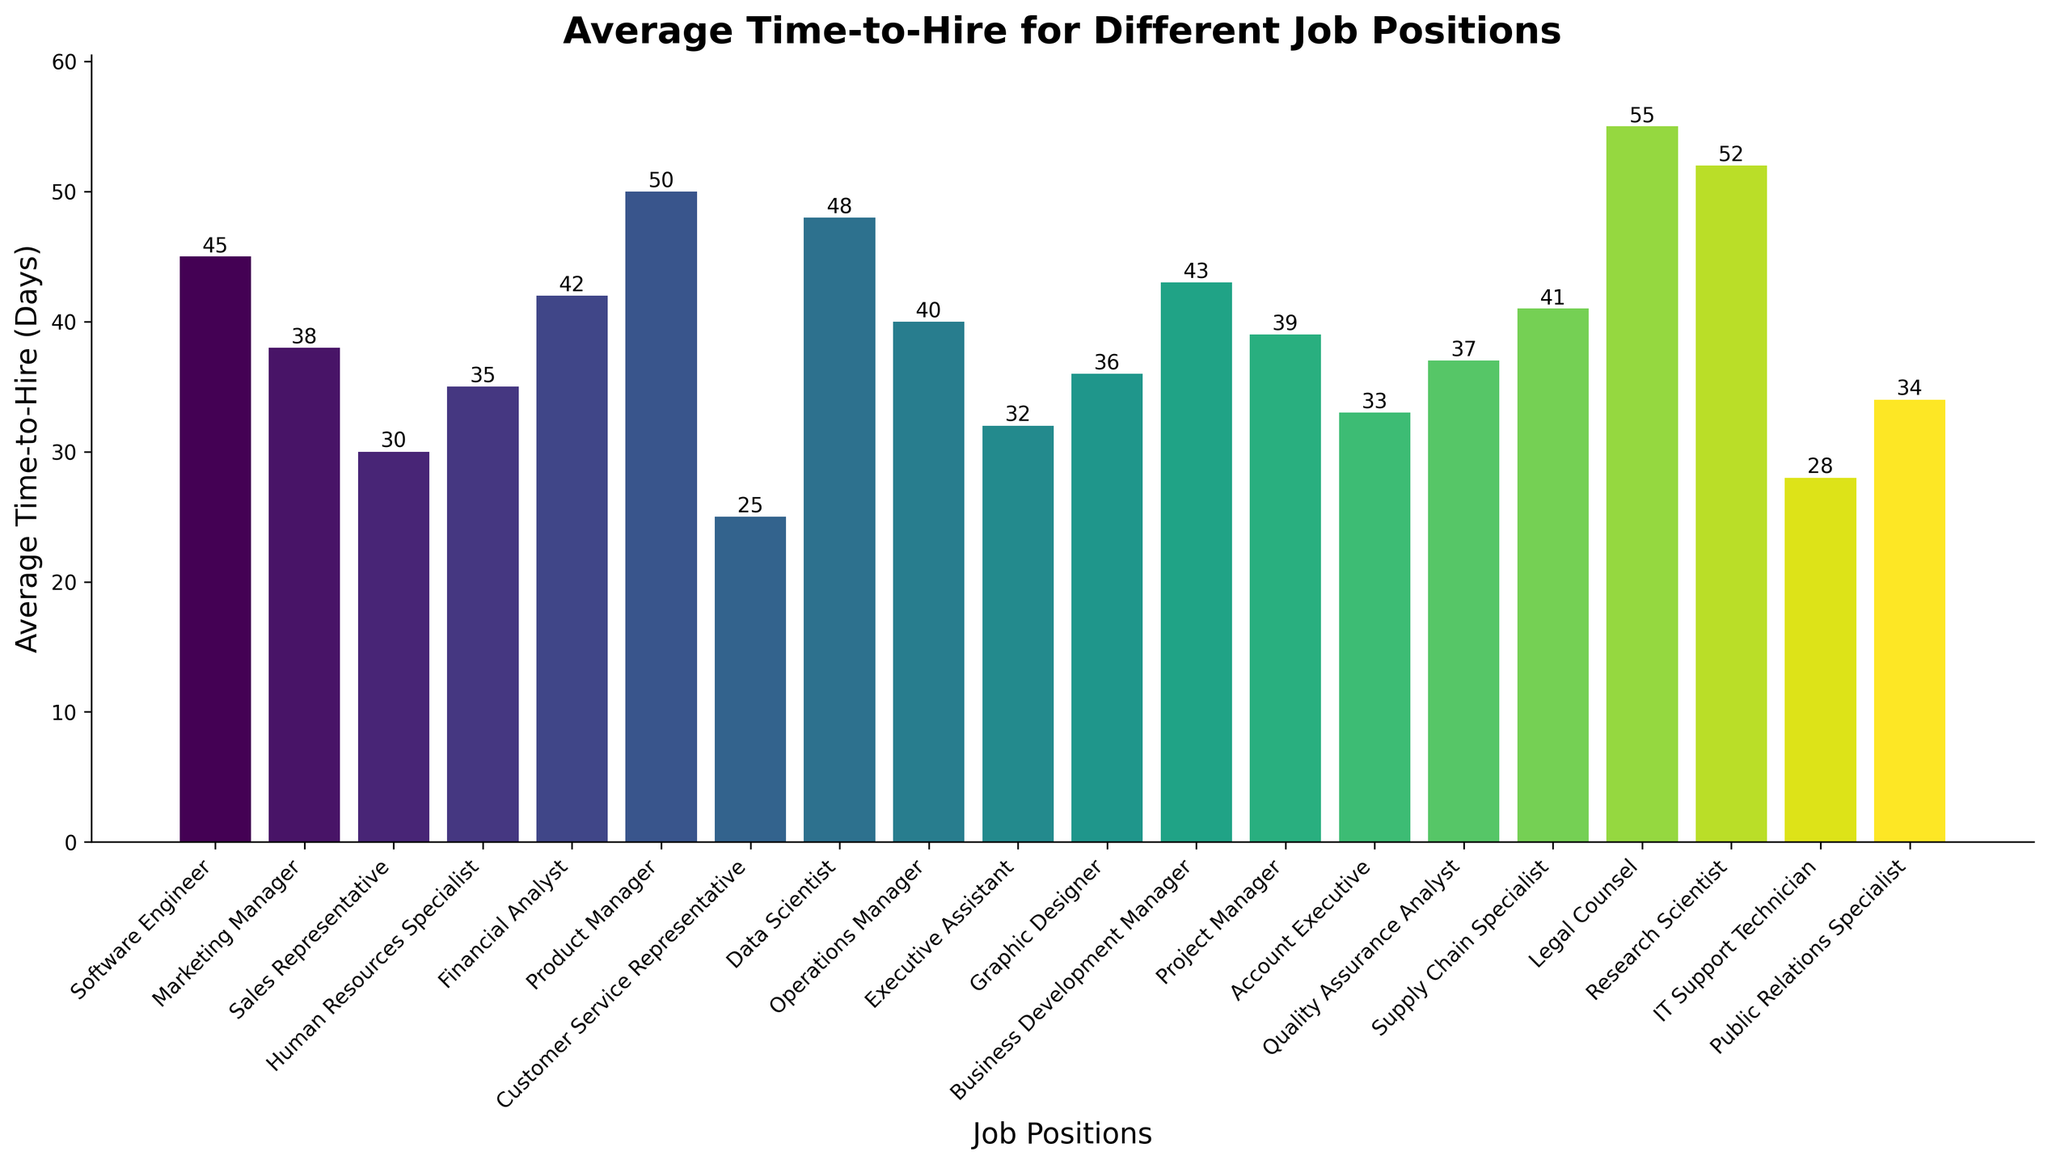What is the job position with the highest average time-to-hire? The position with the tallest bar represents the highest average time-to-hire. By inspecting the chart, we see that Legal Counsel has the highest bar.
Answer: Legal Counsel Which job position has a lower average time-to-hire: Marketing Manager or Sales Representative? By comparing the heights of the bars, the Sales Representative bar is shorter than the Marketing Manager bar. Therefore, the average time-to-hire for Sales Representative is lower.
Answer: Sales Representative What is the average time-to-hire for Project Manager and how does it compare to Executive Assistant? The height of the Project Manager bar shows an average time-to-hire of 39 days, while the Executive Assistant bar shows 32 days. 39 is greater than 32, indicating Project Manager has a higher average time-to-hire.
Answer: Project Manager has a higher average time-to-hire What is the difference in average time-to-hire between Data Scientist and IT Support Technician? The Data Scientist bar height is 48 days, and the IT Support Technician bar height is 28 days. The difference is calculated as 48 - 28 = 20 days.
Answer: 20 days What is the sum of the average time-to-hire for Public Relations Specialist and Financial Analyst? The heights of the bars show Public Relations Specialist at 34 days and Financial Analyst at 42 days. The sum is 34 + 42 = 76 days.
Answer: 76 days Which job position has an average time-to-hire closest to the average time-to-hire for Operations Manager? The Operations Manager bar shows an average time-to-hire of 40 days. Observing the nearby bars, Supply Chain Specialist with 41 days is the closest.
Answer: Supply Chain Specialist How many positions have an average time-to-hire greater than 40 days? By inspecting the chart, we identify non-executive positions where the bars exceed the 40-day mark. These positions include Financial Analyst (42), Product Manager (50), Data Scientist (48), Business Development Manager (43), Supply Chain Specialist (41), Legal Counsel (55), and Research Scientist (52), totaling 7 positions.
Answer: 7 positions What is the combined average time-to-hire for the shortest and longest hiring times? Legal Counsel has the longest average time-to-hire at 55 days, and Customer Service Representative has the shortest at 25 days. The combined time is 55 + 25 = 80 days.
Answer: 80 days 